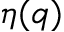Convert formula to latex. <formula><loc_0><loc_0><loc_500><loc_500>\eta ( q )</formula> 